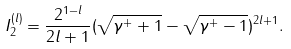Convert formula to latex. <formula><loc_0><loc_0><loc_500><loc_500>I ^ { ( l ) } _ { 2 } = \frac { 2 ^ { 1 - l } } { 2 l + 1 } ( \sqrt { \gamma ^ { + } + 1 } - \sqrt { \gamma ^ { + } - 1 } ) ^ { 2 l + 1 } .</formula> 